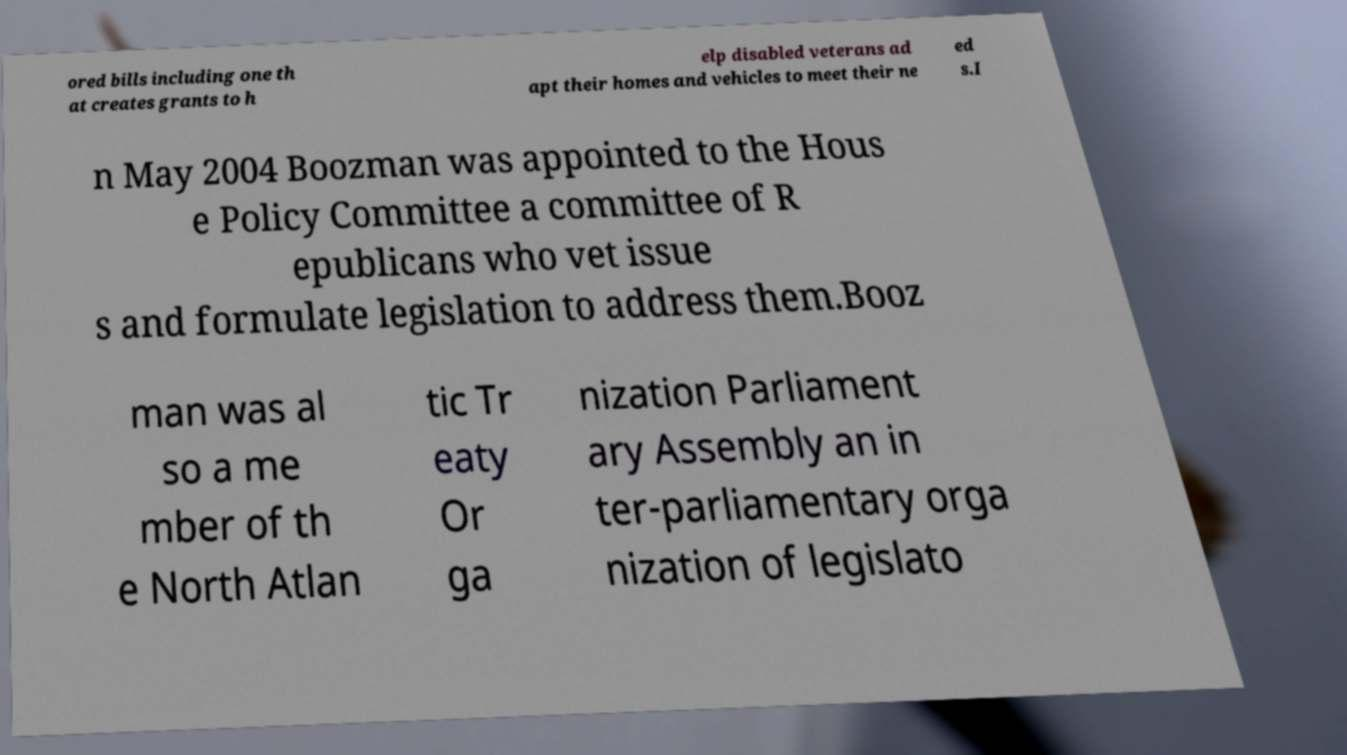Can you read and provide the text displayed in the image?This photo seems to have some interesting text. Can you extract and type it out for me? ored bills including one th at creates grants to h elp disabled veterans ad apt their homes and vehicles to meet their ne ed s.I n May 2004 Boozman was appointed to the Hous e Policy Committee a committee of R epublicans who vet issue s and formulate legislation to address them.Booz man was al so a me mber of th e North Atlan tic Tr eaty Or ga nization Parliament ary Assembly an in ter-parliamentary orga nization of legislato 